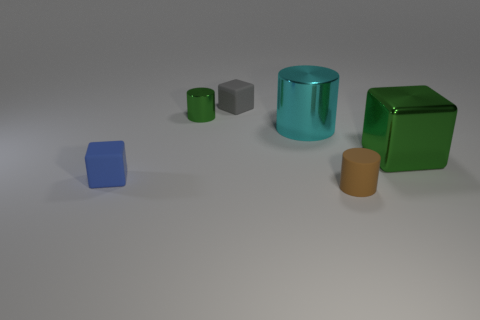Subtract all metallic cylinders. How many cylinders are left? 1 Add 1 small cyan matte cubes. How many objects exist? 7 Subtract all green cylinders. How many cylinders are left? 2 Subtract 2 blocks. How many blocks are left? 1 Add 6 big green metal objects. How many big green metal objects exist? 7 Subtract 1 cyan cylinders. How many objects are left? 5 Subtract all blue cylinders. Subtract all yellow cubes. How many cylinders are left? 3 Subtract all green cubes. How many green cylinders are left? 1 Subtract all red metallic cubes. Subtract all cyan cylinders. How many objects are left? 5 Add 2 small blue matte cubes. How many small blue matte cubes are left? 3 